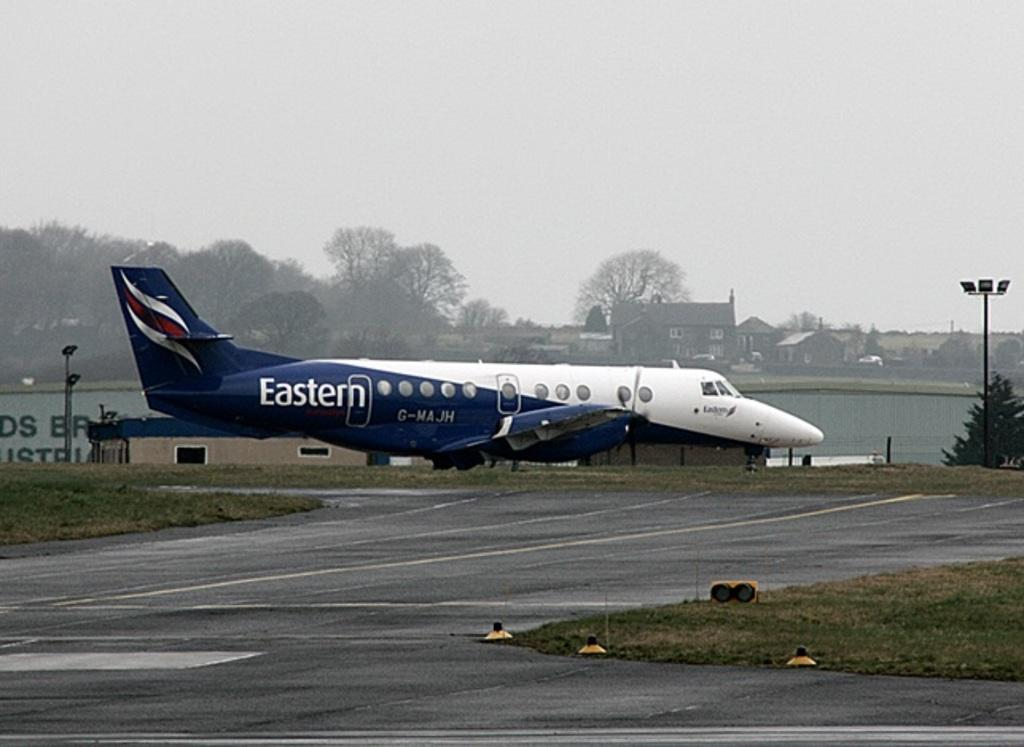<image>
Present a compact description of the photo's key features. A white and blue plane of the airline Eastern is near a runway. 